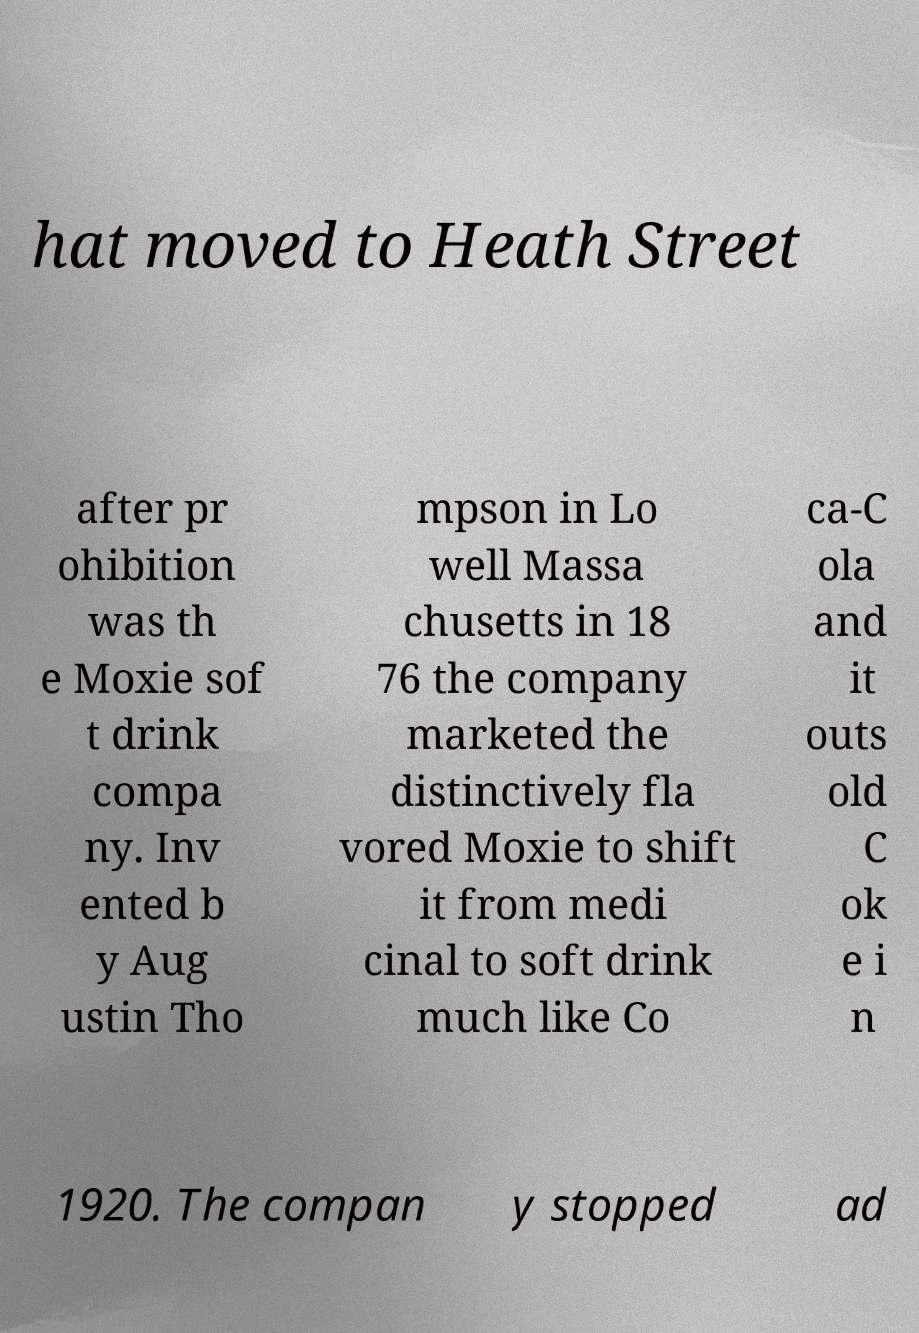Can you accurately transcribe the text from the provided image for me? hat moved to Heath Street after pr ohibition was th e Moxie sof t drink compa ny. Inv ented b y Aug ustin Tho mpson in Lo well Massa chusetts in 18 76 the company marketed the distinctively fla vored Moxie to shift it from medi cinal to soft drink much like Co ca-C ola and it outs old C ok e i n 1920. The compan y stopped ad 